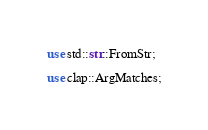Convert code to text. <code><loc_0><loc_0><loc_500><loc_500><_Rust_>use std::str::FromStr;

use clap::ArgMatches;</code> 